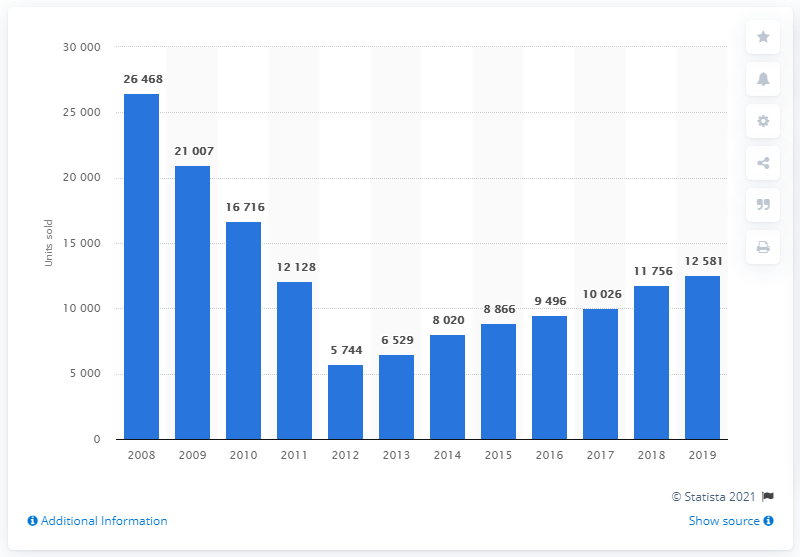Give some essential details in this illustration. The peak of Greek sales of Toyota cars in 2008 was 26,468 units. 